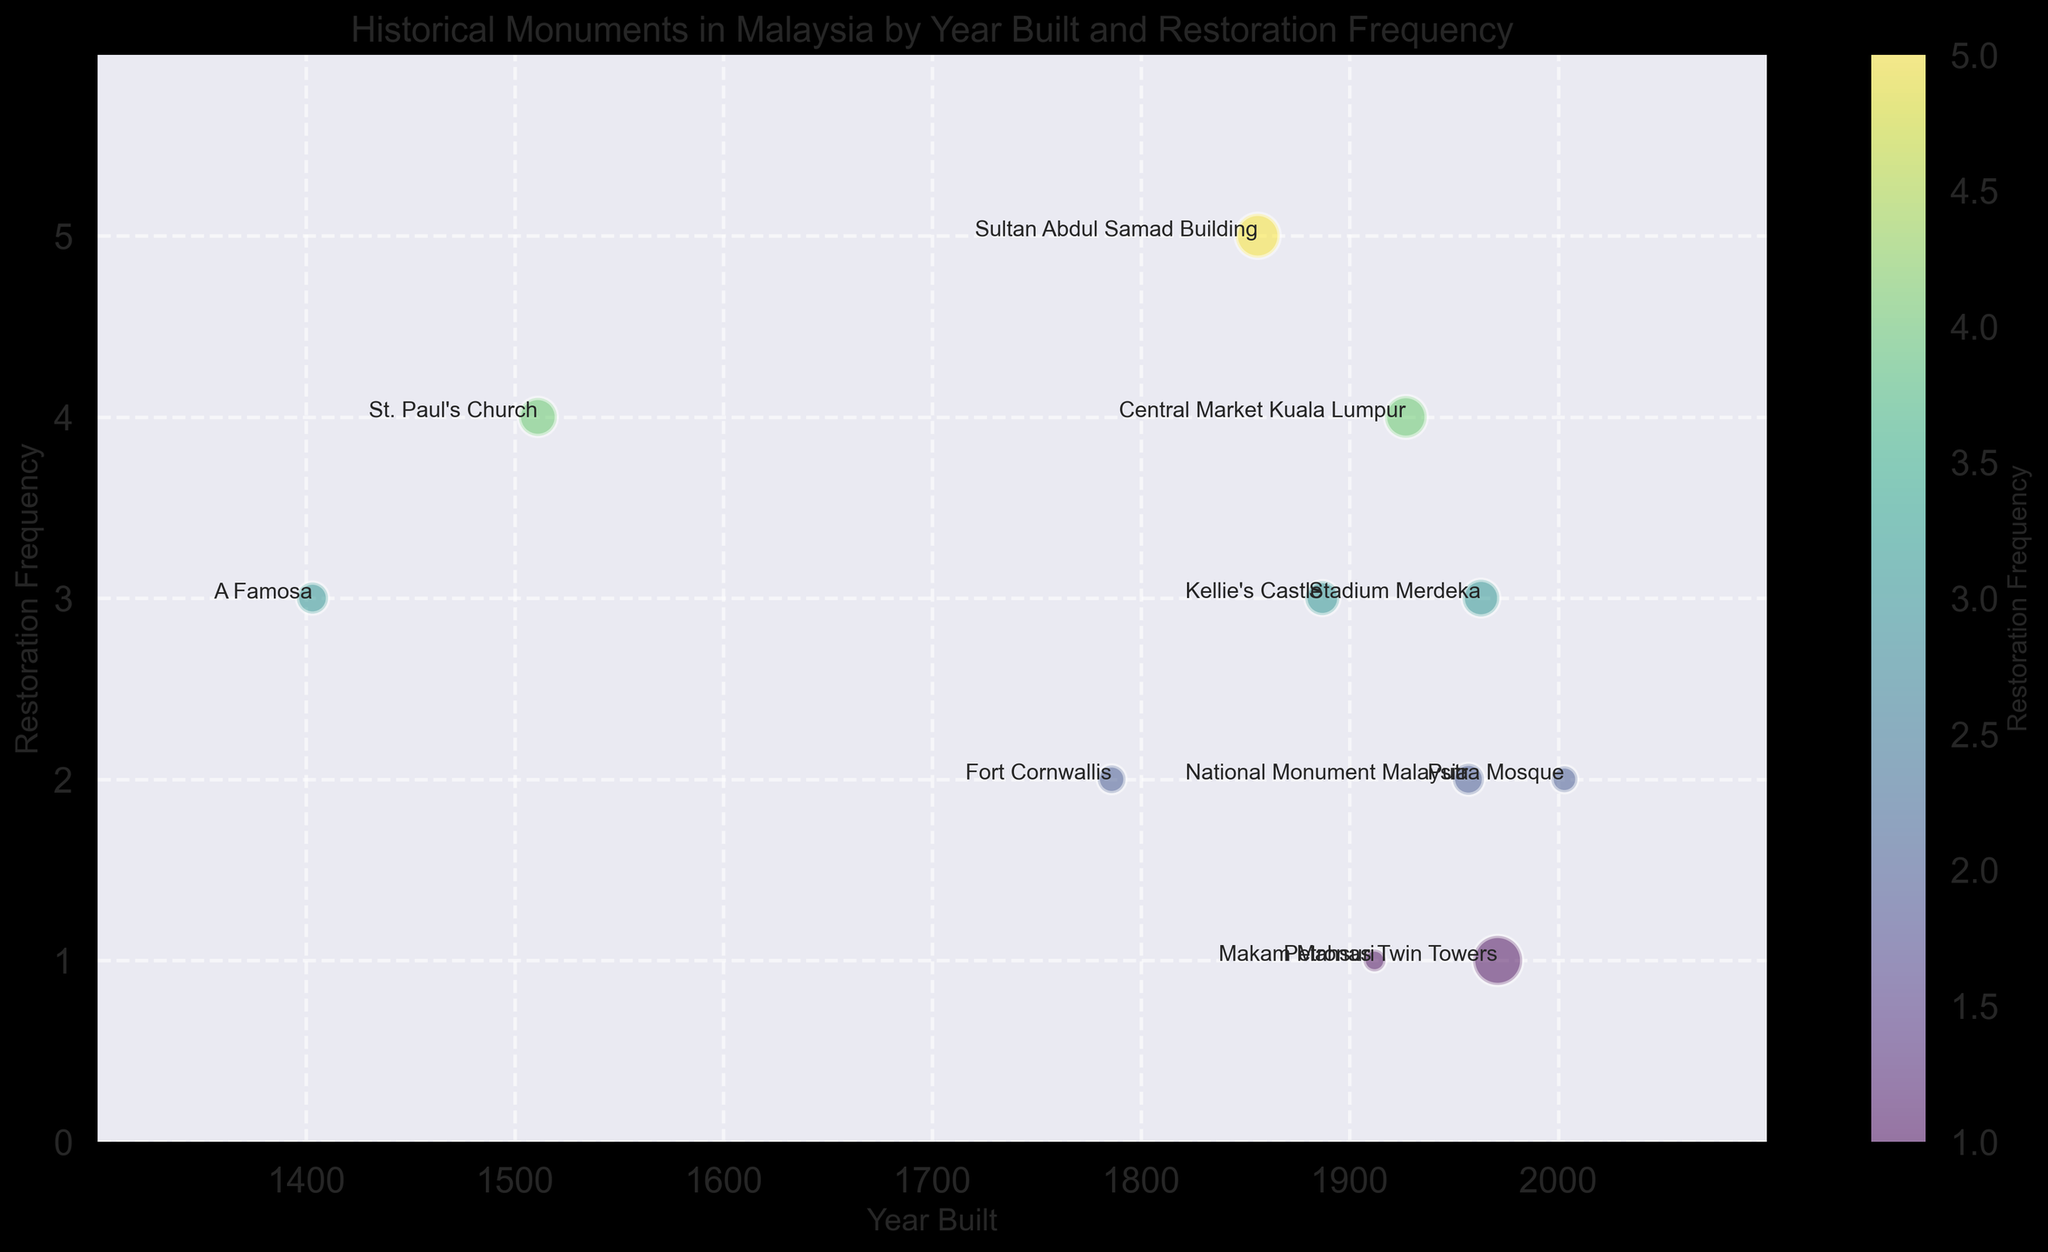What is the oldest monument shown in the figure? Look at the X-axis labeled "Year Built" and find the earliest year, which is 1403, labeled with "A Famosa".
Answer: A Famosa Which monument has the highest restoration frequency? Check the Y-axis labeled "Restoration Frequency" to find the highest value, which is 5. The monument at this value is the "Sultan Abdul Samad Building".
Answer: Sultan Abdul Samad Building Which monument has the largest size bubble in the figure? Observe the relative size of the bubbles and identify the largest one. The largest bubble size corresponds to the "Petronas Twin Towers" with size 25.
Answer: Petronas Twin Towers How many monuments have a restoration frequency of 3? Count the number of bubbles at the Y-value of 3. Three monuments are located there: A Famosa, Kellie's Castle, Stadium Merdeka.
Answer: 3 Which monuments were built before 1900 and have a restoration frequency of 3 or higher? Identify bubbles left of the 1900 mark on the X-axis and check those with Y-values of 3 or greater: A Famosa (3), St. Paul's Church (4), and Kellie's Castle (3).
Answer: A Famosa, St. Paul's Church, Kellie's Castle What is the total restoration frequency of monuments built before 1900? Sum the restoration frequencies for all bubbles left of the 1900 mark: A Famosa (3), St. Paul's Church (4), Fort Cornwallis (2), Sultan Abdul Samad Building (5), Kellie's Castle (3). Total = 3 + 4 + 2 + 5 + 3 = 17.
Answer: 17 Which monument built after 2000 has the least restoration frequency? Examine bubbles right of 2000 on the X-axis and compare Y-values: Putra Mosque (2) and Petronas Twin Towers (1). The least is 1 for Petronas Twin Towers.
Answer: Petronas Twin Towers Which monument built in 1957 has a restoration frequency of 2? Only one bubble is located at X=1957 with Y=2, identified as "National Monument Malaysia".
Answer: National Monument Malaysia Arrange the monuments built in the 20th century (1901-2000) by increasing year built. Identify and order the relevant monuments: Makam Mahsuri (1912), Central Market Kuala Lumpur (1927), National Monument Malaysia (1957), Stadium Merdeka (1963).
Answer: Makam Mahsuri, Central Market Kuala Lumpur, National Monument Malaysia, Stadium Merdeka Which monument shares the same year built and restoration frequency as the Central Market Kuala Lumpur? Match the attributes of "Central Market Kuala Lumpur" (Year Built=1927, Restoration Frequency=4). No other bubble has these exact values.
Answer: None 